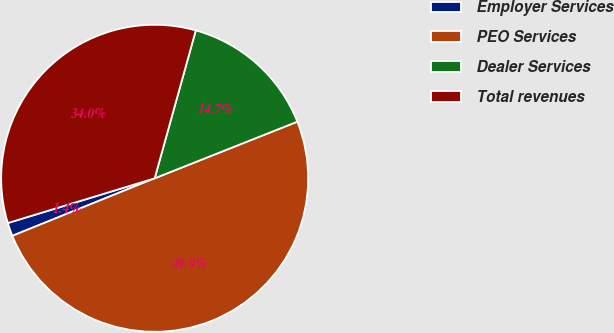Convert chart. <chart><loc_0><loc_0><loc_500><loc_500><pie_chart><fcel>Employer Services<fcel>PEO Services<fcel>Dealer Services<fcel>Total revenues<nl><fcel>1.41%<fcel>49.9%<fcel>14.67%<fcel>34.02%<nl></chart> 